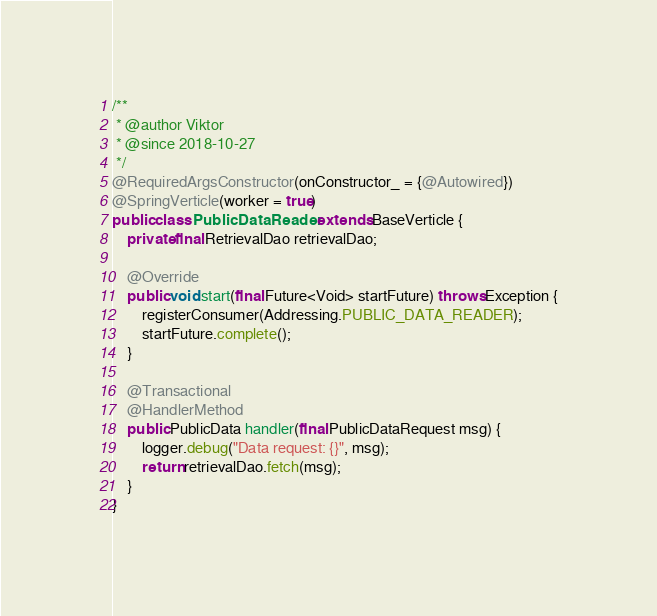Convert code to text. <code><loc_0><loc_0><loc_500><loc_500><_Java_>/**
 * @author Viktor
 * @since 2018-10-27
 */
@RequiredArgsConstructor(onConstructor_ = {@Autowired})
@SpringVerticle(worker = true)
public class PublicDataReader extends BaseVerticle {
    private final RetrievalDao retrievalDao;

    @Override
    public void start(final Future<Void> startFuture) throws Exception {
        registerConsumer(Addressing.PUBLIC_DATA_READER);
        startFuture.complete();
    }

    @Transactional
    @HandlerMethod
    public PublicData handler(final PublicDataRequest msg) {
        logger.debug("Data request: {}", msg);
        return retrievalDao.fetch(msg);
    }
}
</code> 